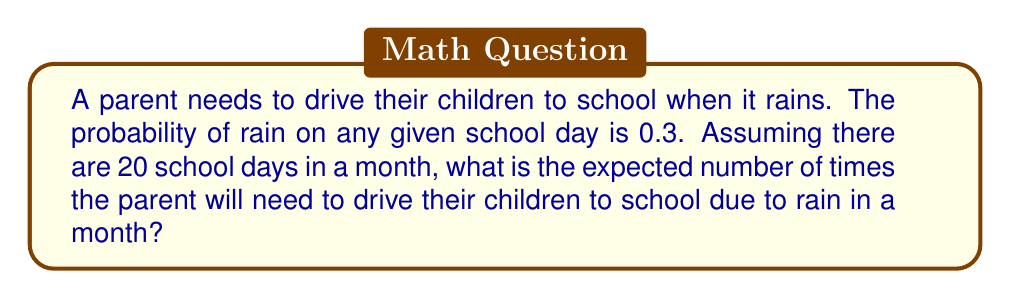Provide a solution to this math problem. To solve this problem, we'll use the concept of expected value in a binomial distribution:

1) Let X be the random variable representing the number of rainy days in a month.

2) Each day can be considered a Bernoulli trial with probability of success (rain) p = 0.3.

3) There are n = 20 school days in a month.

4) This scenario follows a binomial distribution with parameters n and p.

5) The expected value of a binomial distribution is given by:

   $$ E(X) = np $$

6) Substituting our values:

   $$ E(X) = 20 * 0.3 = 6 $$

Therefore, the expected number of times the parent needs to drive their children to school due to rain in a month is 6.
Answer: 6 times 